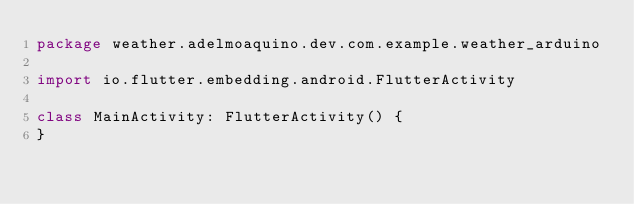Convert code to text. <code><loc_0><loc_0><loc_500><loc_500><_Kotlin_>package weather.adelmoaquino.dev.com.example.weather_arduino

import io.flutter.embedding.android.FlutterActivity

class MainActivity: FlutterActivity() {
}
</code> 